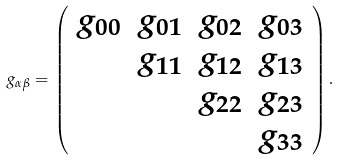Convert formula to latex. <formula><loc_0><loc_0><loc_500><loc_500>g _ { \alpha \beta } = \left ( \begin{array} { c c c c } g _ { 0 0 } & g _ { 0 1 } & g _ { 0 2 } & g _ { 0 3 } \\ & g _ { 1 1 } & g _ { 1 2 } & g _ { 1 3 } \\ & & g _ { 2 2 } & g _ { 2 3 } \\ & & & g _ { 3 3 } \\ \end{array} \right ) .</formula> 